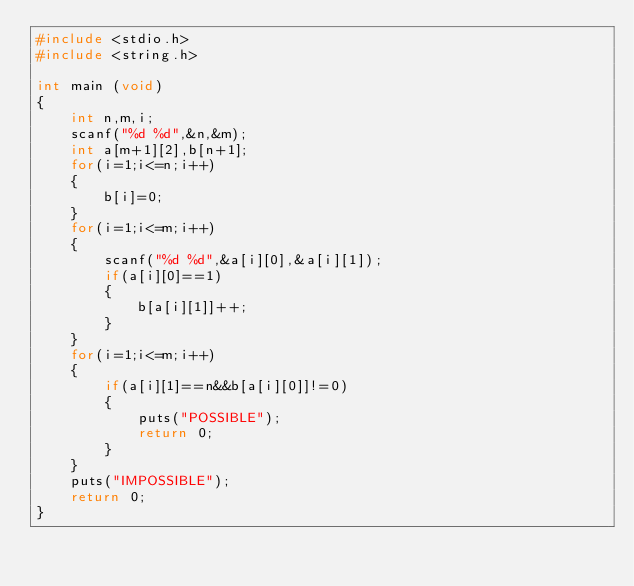Convert code to text. <code><loc_0><loc_0><loc_500><loc_500><_C_>#include <stdio.h>
#include <string.h>

int main (void)
{
    int n,m,i;
    scanf("%d %d",&n,&m);
    int a[m+1][2],b[n+1];
    for(i=1;i<=n;i++)
    {
        b[i]=0;
    }
    for(i=1;i<=m;i++)
    {
        scanf("%d %d",&a[i][0],&a[i][1]);
        if(a[i][0]==1)
        {
            b[a[i][1]]++;
        }
    }
    for(i=1;i<=m;i++)
    {
        if(a[i][1]==n&&b[a[i][0]]!=0)
        {
            puts("POSSIBLE");
            return 0;
        }
    }
    puts("IMPOSSIBLE");
    return 0;
}</code> 